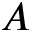<formula> <loc_0><loc_0><loc_500><loc_500>A</formula> 